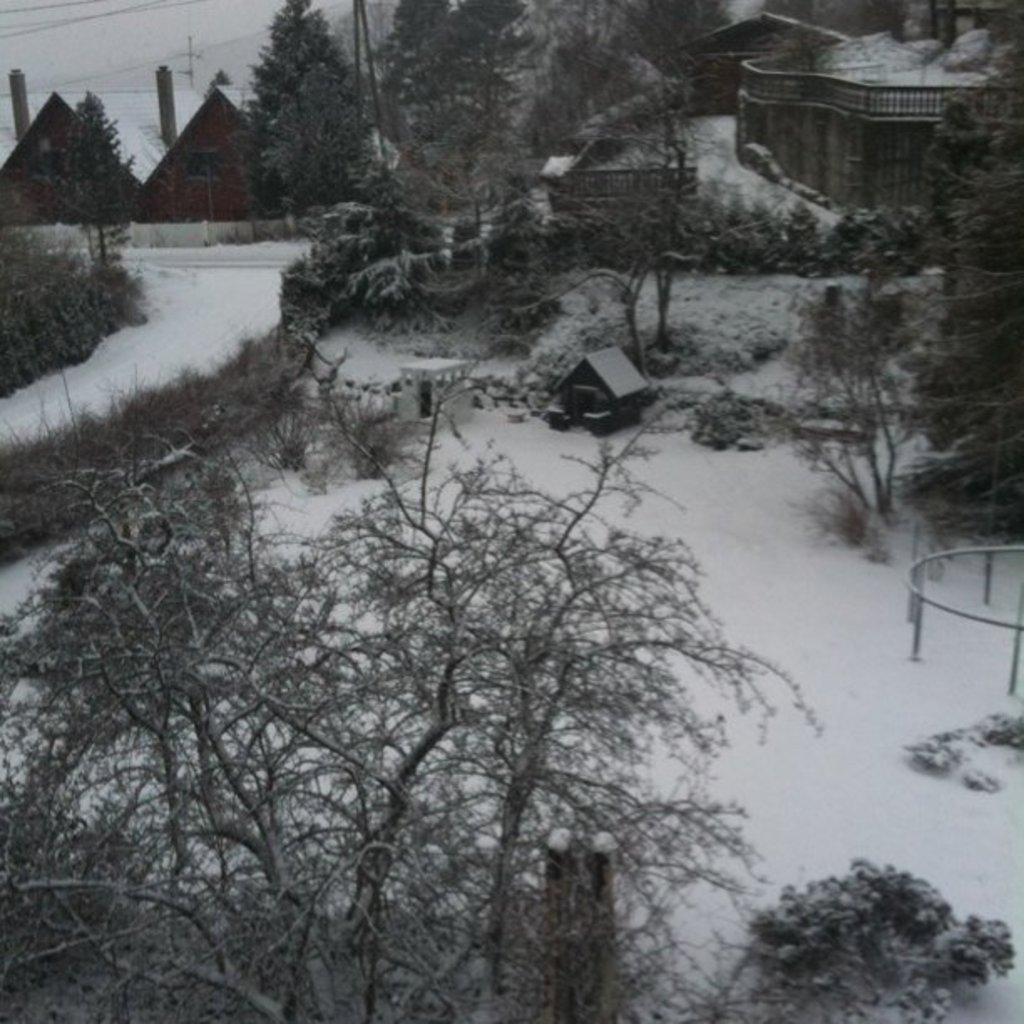What type of weather is depicted in the image? There is snow in the image, indicating a snowy or wintry weather. What type of vegetation is present in the image? There are trees in the image. What type of structure is visible in the image? There is a house in the image. What part of the house is specifically mentioned in the facts? There are chimneys in the image. What is visible in the sky in the image? The sky is visible in the image. Can you tell me how many quinces are hanging from the trees in the image? There is no mention of quinces in the image; it features snow, trees, a house, and chimneys. What type of yoke is being used by the porter in the image? There is no porter or yoke present in the image. 